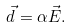Convert formula to latex. <formula><loc_0><loc_0><loc_500><loc_500>\vec { d } = \alpha \vec { E } .</formula> 